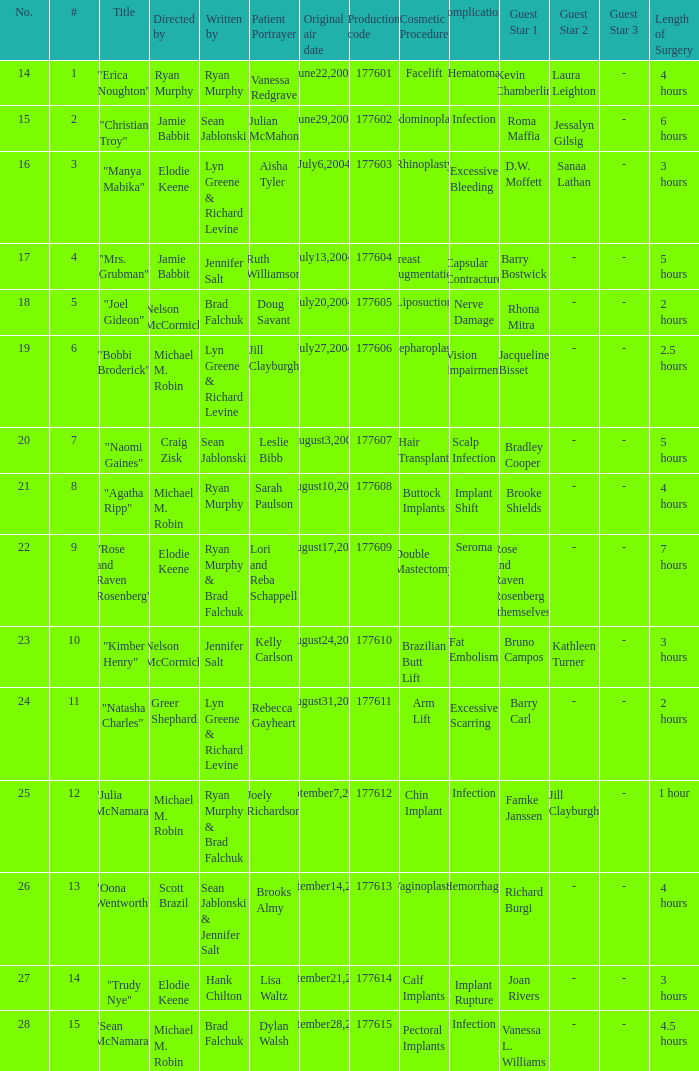What numbered episode is titled "naomi gaines"? 20.0. 